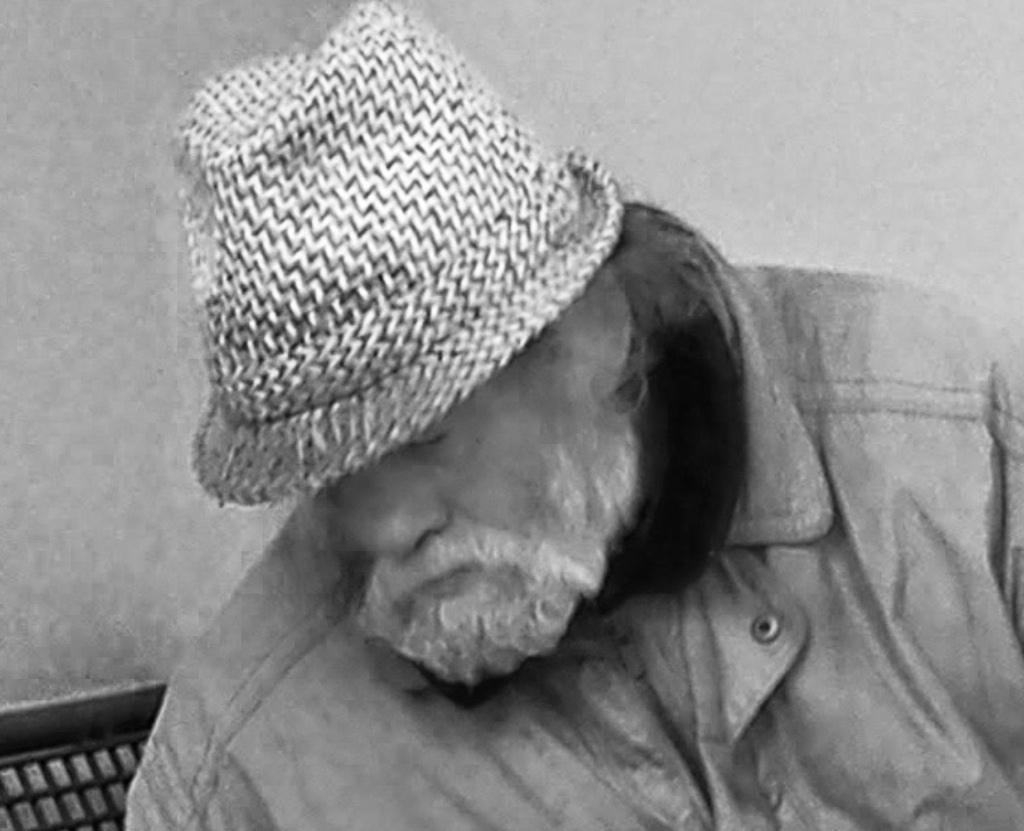In one or two sentences, can you explain what this image depicts? In this picture we can see a person wearing a cap. We can see an object and a wall in the background. 